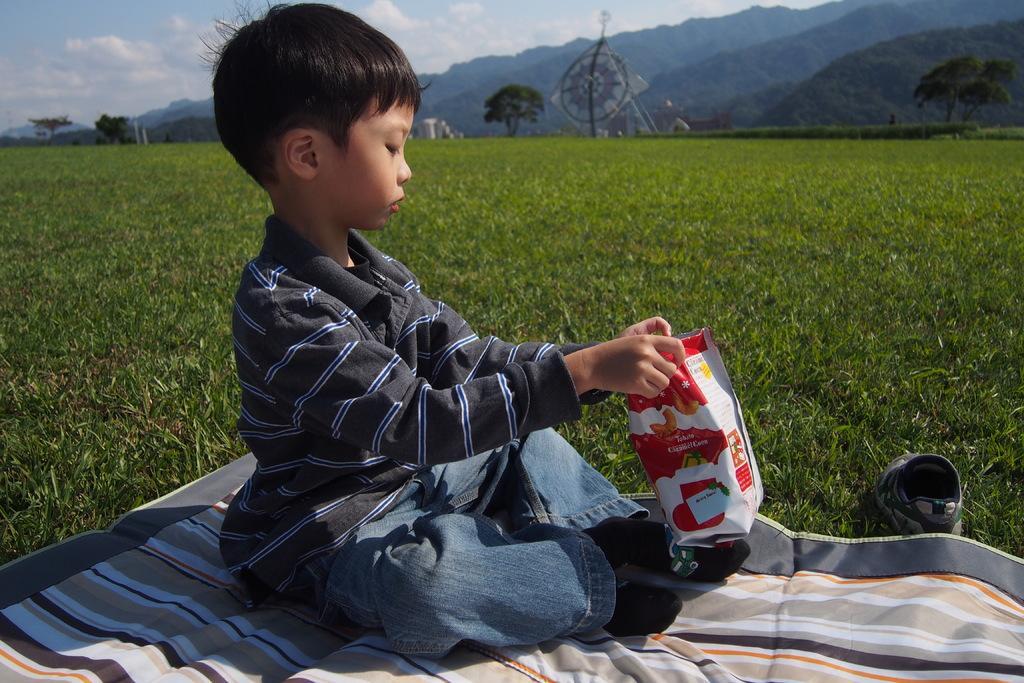Describe this image in one or two sentences. In this image we can see a boy is sitting. He is wearing T-shirt, jeans and carry bag in his hand. We can see one shoe on the right side of the image. In the background, we can see grassy land, trees, mountains and one object. At the top of the image, we can see the sky with some clouds. At the bottom of the image, we can see a cloth. 